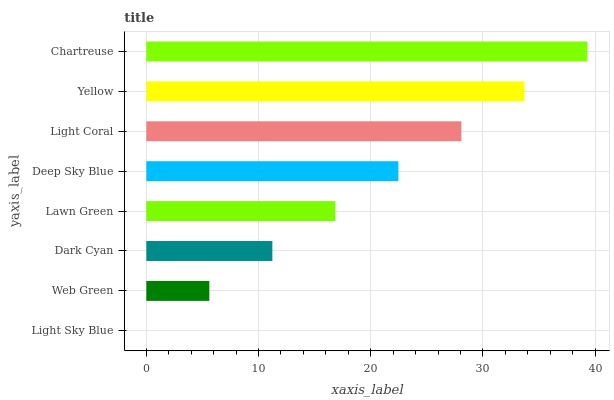Is Light Sky Blue the minimum?
Answer yes or no. Yes. Is Chartreuse the maximum?
Answer yes or no. Yes. Is Web Green the minimum?
Answer yes or no. No. Is Web Green the maximum?
Answer yes or no. No. Is Web Green greater than Light Sky Blue?
Answer yes or no. Yes. Is Light Sky Blue less than Web Green?
Answer yes or no. Yes. Is Light Sky Blue greater than Web Green?
Answer yes or no. No. Is Web Green less than Light Sky Blue?
Answer yes or no. No. Is Deep Sky Blue the high median?
Answer yes or no. Yes. Is Lawn Green the low median?
Answer yes or no. Yes. Is Chartreuse the high median?
Answer yes or no. No. Is Light Coral the low median?
Answer yes or no. No. 